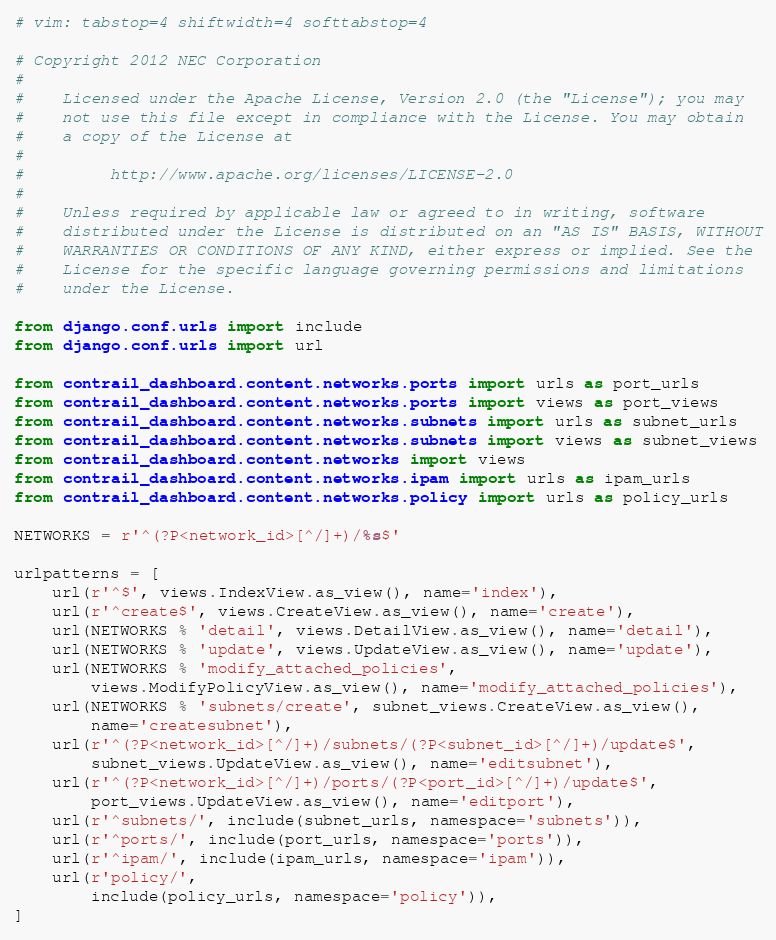Convert code to text. <code><loc_0><loc_0><loc_500><loc_500><_Python_># vim: tabstop=4 shiftwidth=4 softtabstop=4

# Copyright 2012 NEC Corporation
#
#    Licensed under the Apache License, Version 2.0 (the "License"); you may
#    not use this file except in compliance with the License. You may obtain
#    a copy of the License at
#
#         http://www.apache.org/licenses/LICENSE-2.0
#
#    Unless required by applicable law or agreed to in writing, software
#    distributed under the License is distributed on an "AS IS" BASIS, WITHOUT
#    WARRANTIES OR CONDITIONS OF ANY KIND, either express or implied. See the
#    License for the specific language governing permissions and limitations
#    under the License.

from django.conf.urls import include
from django.conf.urls import url

from contrail_dashboard.content.networks.ports import urls as port_urls
from contrail_dashboard.content.networks.ports import views as port_views
from contrail_dashboard.content.networks.subnets import urls as subnet_urls
from contrail_dashboard.content.networks.subnets import views as subnet_views
from contrail_dashboard.content.networks import views
from contrail_dashboard.content.networks.ipam import urls as ipam_urls
from contrail_dashboard.content.networks.policy import urls as policy_urls

NETWORKS = r'^(?P<network_id>[^/]+)/%s$'

urlpatterns = [
    url(r'^$', views.IndexView.as_view(), name='index'),
    url(r'^create$', views.CreateView.as_view(), name='create'),
    url(NETWORKS % 'detail', views.DetailView.as_view(), name='detail'),
    url(NETWORKS % 'update', views.UpdateView.as_view(), name='update'),
    url(NETWORKS % 'modify_attached_policies',
        views.ModifyPolicyView.as_view(), name='modify_attached_policies'),
    url(NETWORKS % 'subnets/create', subnet_views.CreateView.as_view(),
        name='createsubnet'),
    url(r'^(?P<network_id>[^/]+)/subnets/(?P<subnet_id>[^/]+)/update$',
        subnet_views.UpdateView.as_view(), name='editsubnet'),
    url(r'^(?P<network_id>[^/]+)/ports/(?P<port_id>[^/]+)/update$',
        port_views.UpdateView.as_view(), name='editport'),
    url(r'^subnets/', include(subnet_urls, namespace='subnets')),
    url(r'^ports/', include(port_urls, namespace='ports')),
    url(r'^ipam/', include(ipam_urls, namespace='ipam')),
    url(r'policy/',
        include(policy_urls, namespace='policy')),
]
</code> 